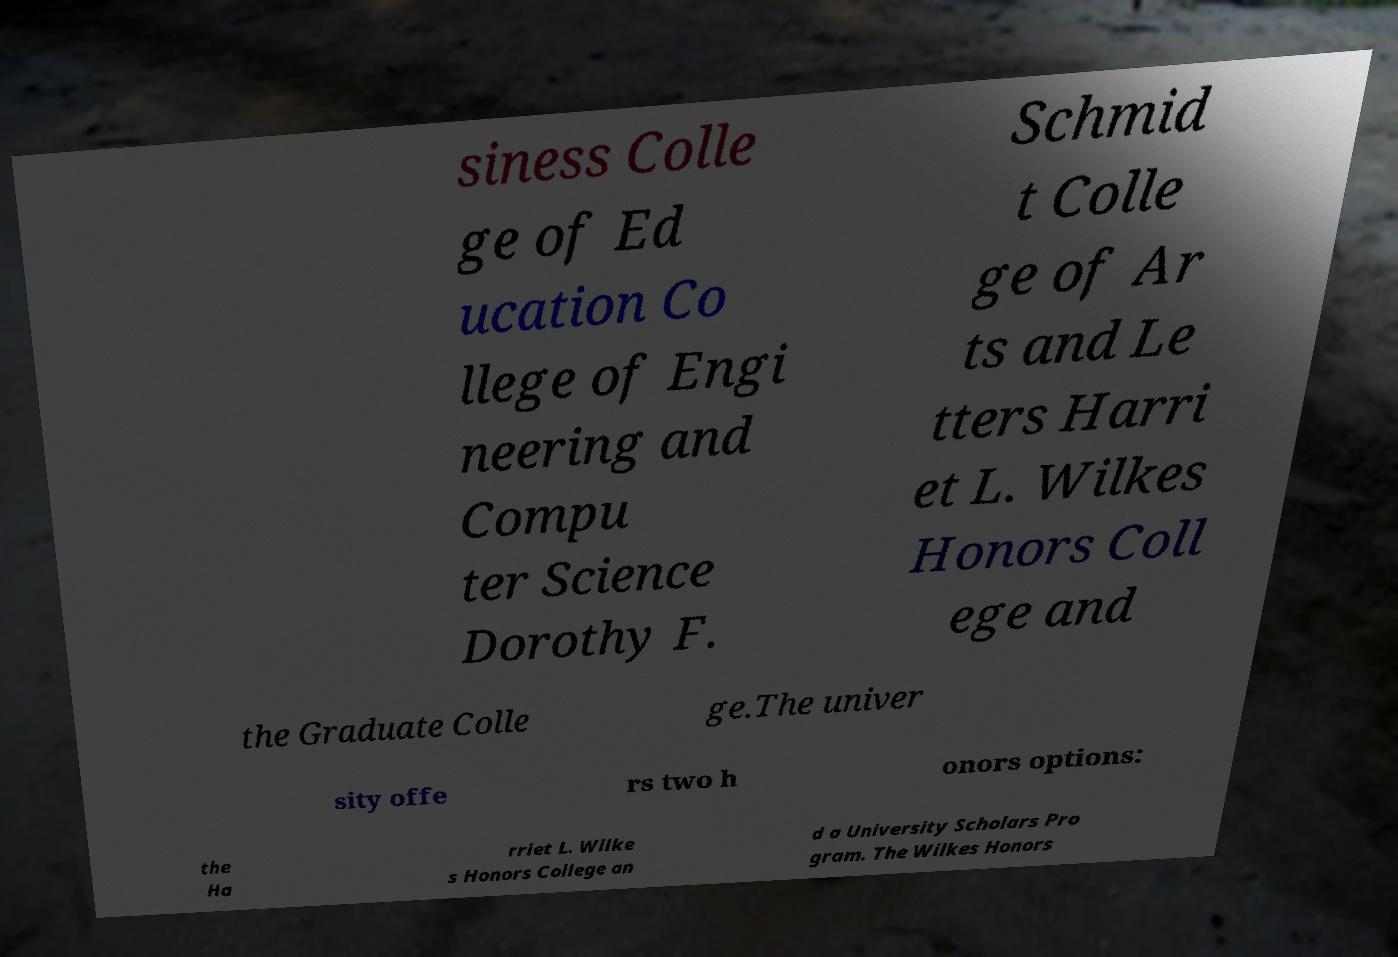Could you assist in decoding the text presented in this image and type it out clearly? siness Colle ge of Ed ucation Co llege of Engi neering and Compu ter Science Dorothy F. Schmid t Colle ge of Ar ts and Le tters Harri et L. Wilkes Honors Coll ege and the Graduate Colle ge.The univer sity offe rs two h onors options: the Ha rriet L. Wilke s Honors College an d a University Scholars Pro gram. The Wilkes Honors 